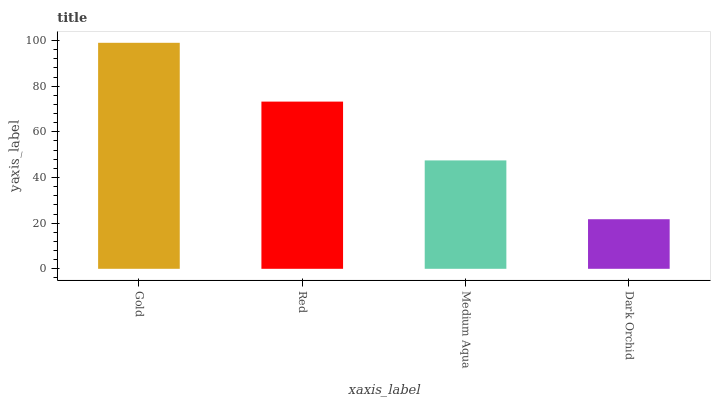Is Gold the maximum?
Answer yes or no. Yes. Is Red the minimum?
Answer yes or no. No. Is Red the maximum?
Answer yes or no. No. Is Gold greater than Red?
Answer yes or no. Yes. Is Red less than Gold?
Answer yes or no. Yes. Is Red greater than Gold?
Answer yes or no. No. Is Gold less than Red?
Answer yes or no. No. Is Red the high median?
Answer yes or no. Yes. Is Medium Aqua the low median?
Answer yes or no. Yes. Is Gold the high median?
Answer yes or no. No. Is Dark Orchid the low median?
Answer yes or no. No. 